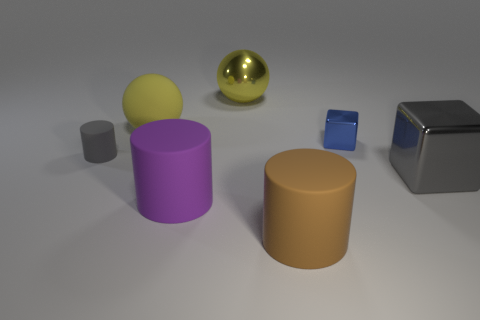Is the number of large shiny spheres that are right of the gray block less than the number of big brown objects?
Give a very brief answer. Yes. Is the material of the cube behind the gray cylinder the same as the big cube?
Provide a short and direct response. Yes. There is a tiny object that is made of the same material as the purple cylinder; what is its color?
Provide a succinct answer. Gray. Is the number of small gray objects in front of the purple cylinder less than the number of brown matte cylinders that are in front of the big brown matte object?
Keep it short and to the point. No. There is a large ball that is left of the big metallic ball; does it have the same color as the block that is on the right side of the blue metallic thing?
Give a very brief answer. No. Are there any big gray things made of the same material as the brown cylinder?
Provide a short and direct response. No. What size is the cube to the left of the gray thing in front of the gray cylinder?
Provide a succinct answer. Small. Is the number of things greater than the number of purple cylinders?
Make the answer very short. Yes. There is a yellow rubber sphere that is behind the purple rubber thing; does it have the same size as the brown cylinder?
Provide a short and direct response. Yes. What number of large metal cubes have the same color as the small cylinder?
Keep it short and to the point. 1. 